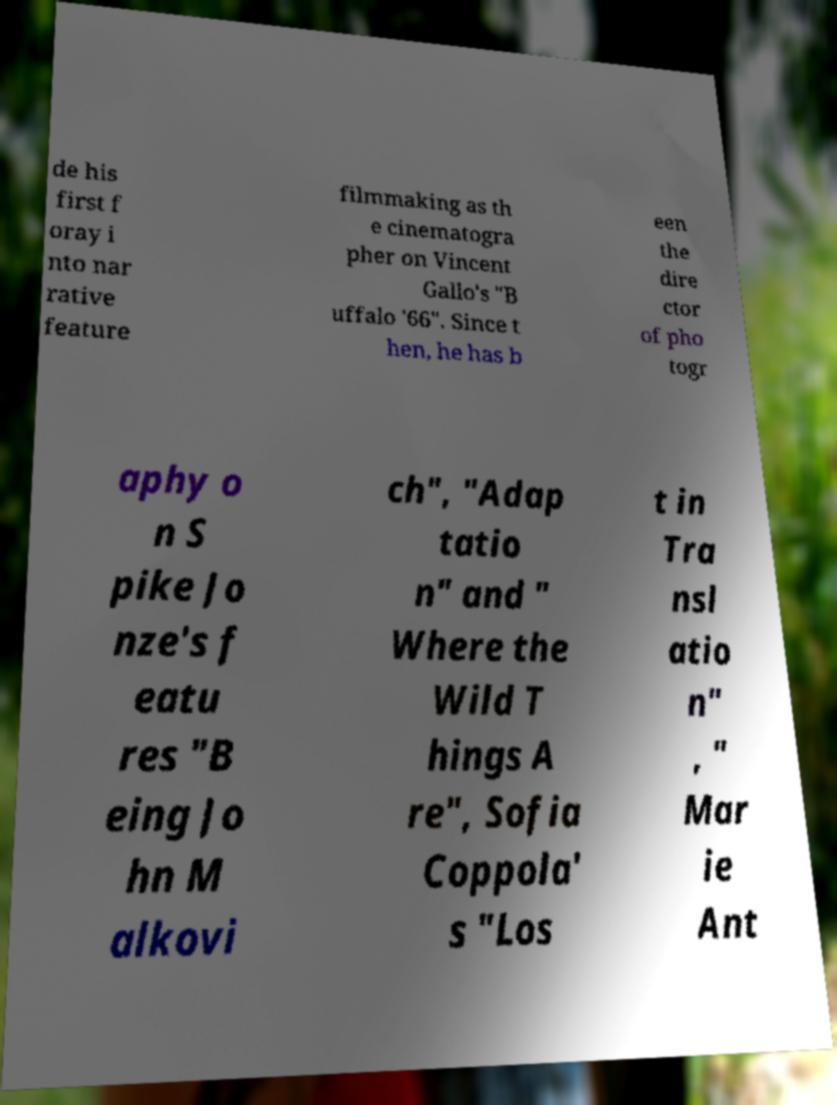Can you accurately transcribe the text from the provided image for me? de his first f oray i nto nar rative feature filmmaking as th e cinematogra pher on Vincent Gallo's "B uffalo '66". Since t hen, he has b een the dire ctor of pho togr aphy o n S pike Jo nze's f eatu res "B eing Jo hn M alkovi ch", "Adap tatio n" and " Where the Wild T hings A re", Sofia Coppola' s "Los t in Tra nsl atio n" , " Mar ie Ant 